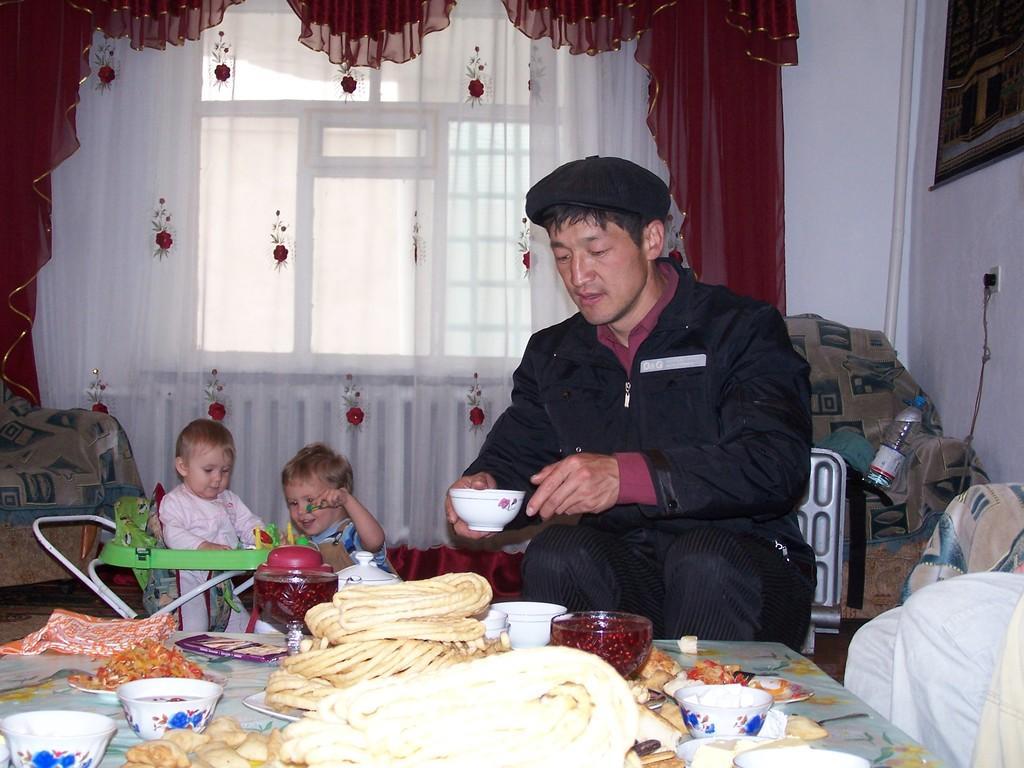Could you give a brief overview of what you see in this image? In this picture, we can see a few people sitting, and a few are holding some objects, we can see the ground with some objects like chairs, table and some objects on the table like some food items served in plates, containers, and we can see some objects on the right side of picture like bottle, pipe, and we can see the wall with windows, curtains, frame, switch board with wire, and we can see a baby with green color object. 